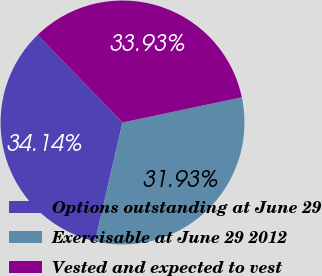<chart> <loc_0><loc_0><loc_500><loc_500><pie_chart><fcel>Options outstanding at June 29<fcel>Exercisable at June 29 2012<fcel>Vested and expected to vest<nl><fcel>34.14%<fcel>31.93%<fcel>33.93%<nl></chart> 